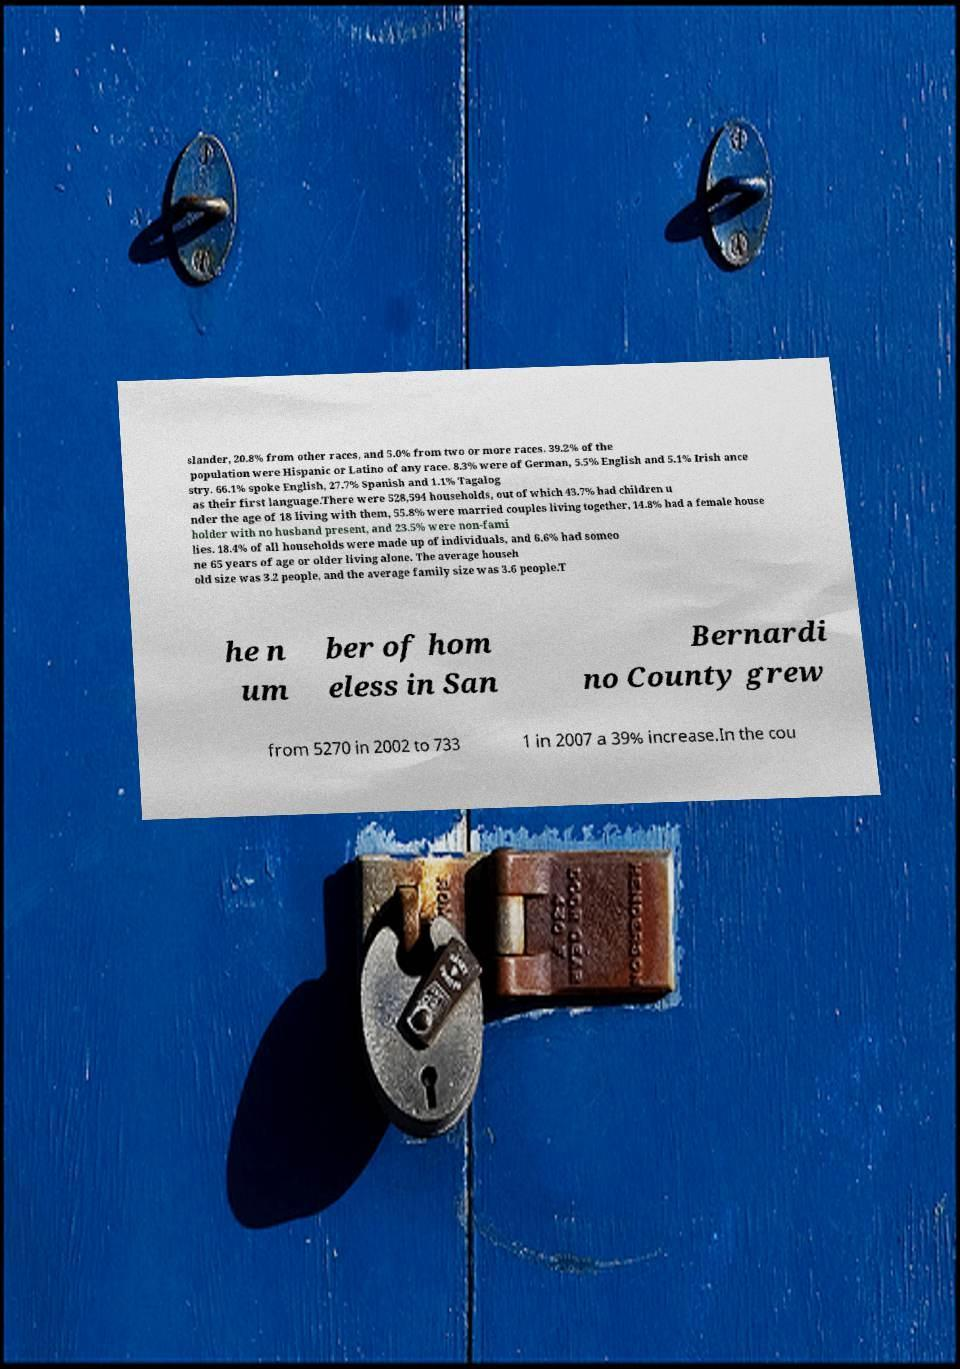There's text embedded in this image that I need extracted. Can you transcribe it verbatim? slander, 20.8% from other races, and 5.0% from two or more races. 39.2% of the population were Hispanic or Latino of any race. 8.3% were of German, 5.5% English and 5.1% Irish ance stry. 66.1% spoke English, 27.7% Spanish and 1.1% Tagalog as their first language.There were 528,594 households, out of which 43.7% had children u nder the age of 18 living with them, 55.8% were married couples living together, 14.8% had a female house holder with no husband present, and 23.5% were non-fami lies. 18.4% of all households were made up of individuals, and 6.6% had someo ne 65 years of age or older living alone. The average househ old size was 3.2 people, and the average family size was 3.6 people.T he n um ber of hom eless in San Bernardi no County grew from 5270 in 2002 to 733 1 in 2007 a 39% increase.In the cou 